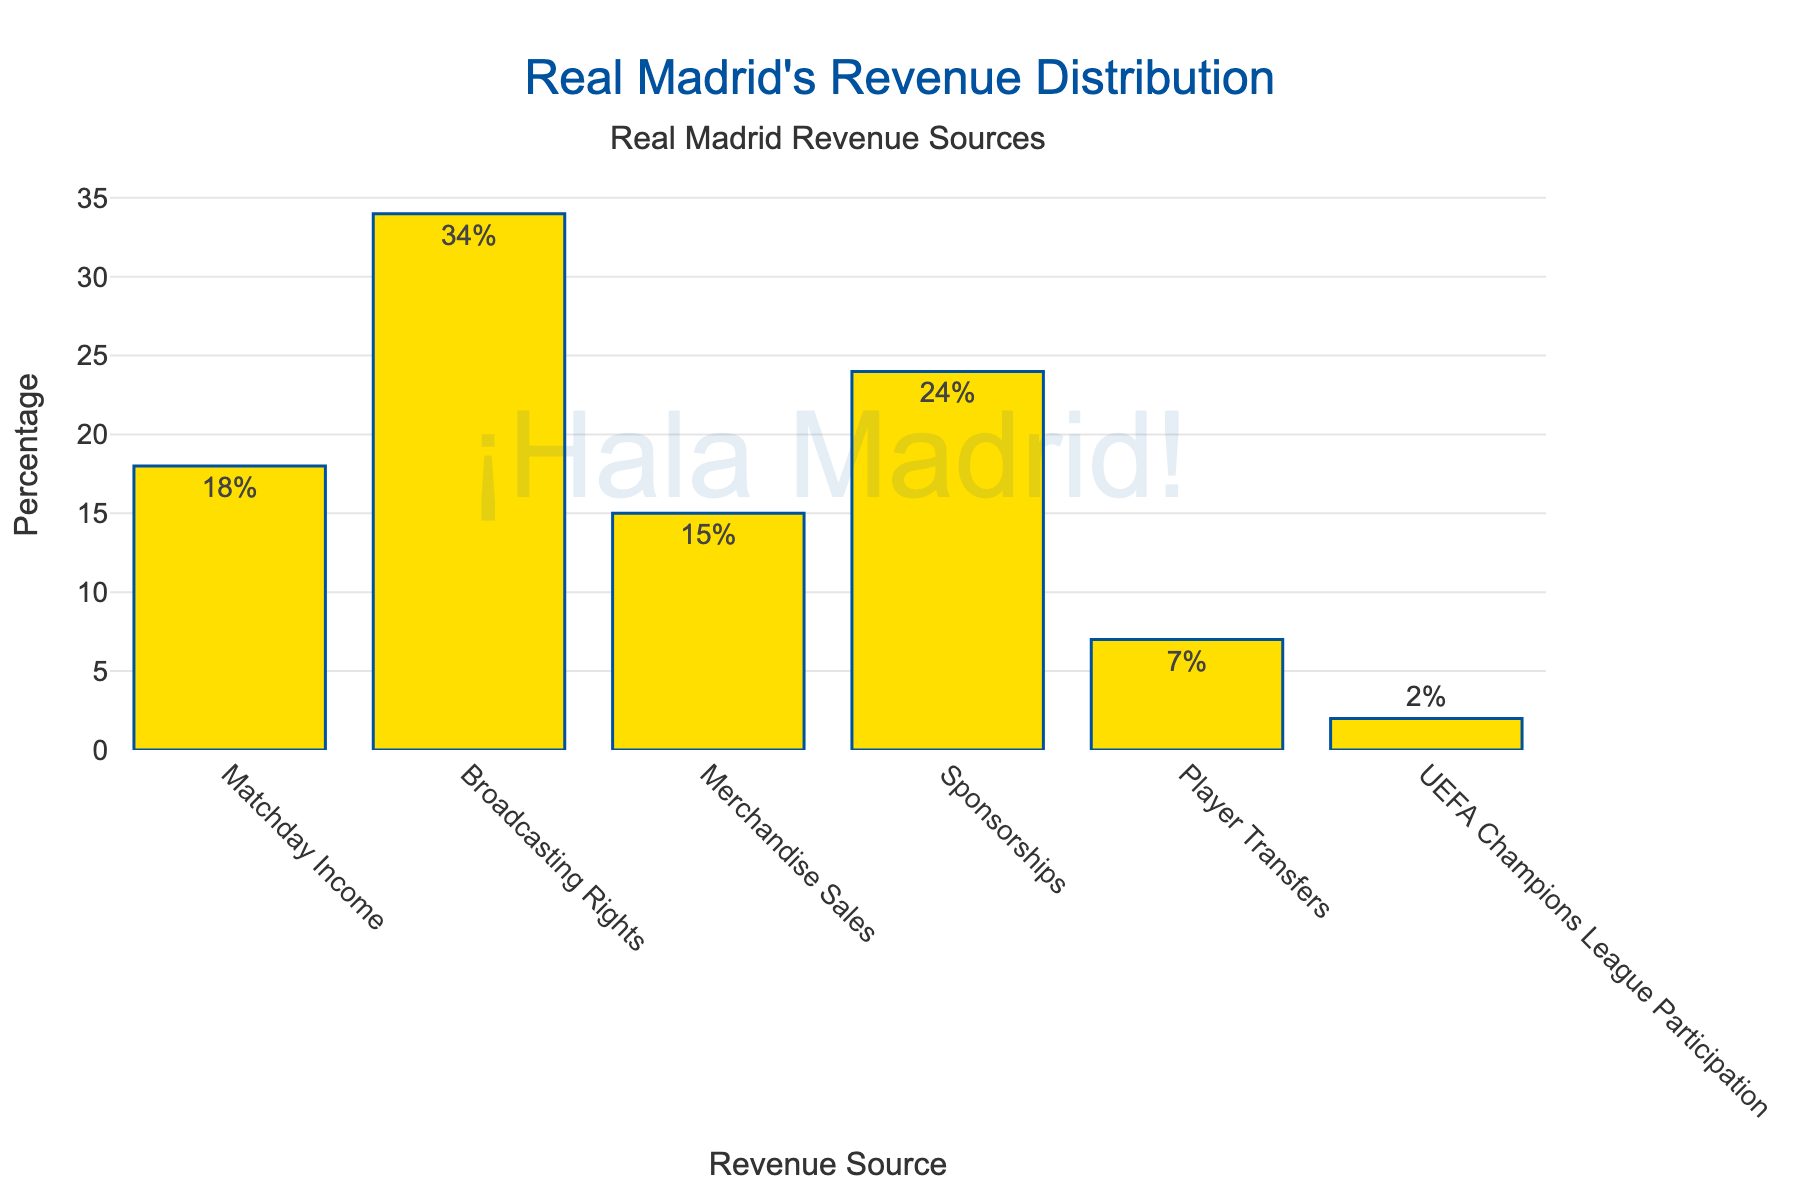What is the revenue source with the highest percentage? The bar with the greatest height represents the revenue source with the highest percentage. By looking at the chart, we see that "Broadcasting Rights" has the highest percentage.
Answer: Broadcasting Rights How much higher is the percentage of Broadcasting Rights compared to Merchandise Sales? To find the difference, subtract the percentage of Merchandise Sales from the percentage of Broadcasting Rights. Broadcasting Rights is 34%, and Merchandise Sales is 15%, so 34% - 15% = 19%.
Answer: 19% What is the total percentage of revenue coming from Matchday Income and Player Transfers combined? Add the percentages from Matchday Income and Player Transfers. Matchday Income is 18%, and Player Transfers is 7%, so 18% + 7% = 25%.
Answer: 25% Which revenue source contributes the least to the total revenue? The shortest bar indicates the least contributing revenue source. From the chart, "UEFA Champions League Participation" is the shortest bar at 2%.
Answer: UEFA Champions League Participation Are the percentages of Sponsorships and Merchandise Sales together greater than the percentage of Broadcasting Rights? First, add the percentages of Sponsorships and Merchandise Sales. Sponsorships is 24% and Merchandise Sales is 15%. Together, 24% + 15% = 39%, which is greater than 34% for Broadcasting Rights.
Answer: Yes How does the percentage of Sponsorships compare to the percentage of Matchday Income? Check the height of the bars for Sponsorships and Matchday Income. Sponsorships at 24% is represented by a taller bar compared to Matchday Income at 18%.
Answer: Sponsorships is higher What is the average percentage of revenue sources excluding Broadcasting Rights? Add up the percentages of all other sources and divide by the number of sources excluding Broadcasting Rights. (18% + 15% + 24% + 7% + 2%) / 5 = 66% / 5 = 13.2%.
Answer: 13.2% Is the percentage of revenue from Player Transfers double the percentage from UEFA Champions League Participation? Compare the percentage of Player Transfers (7%) to double the percentage of UEFA Champions League Participation (2% * 2 = 4%). 7% is greater than 4%.
Answer: No 